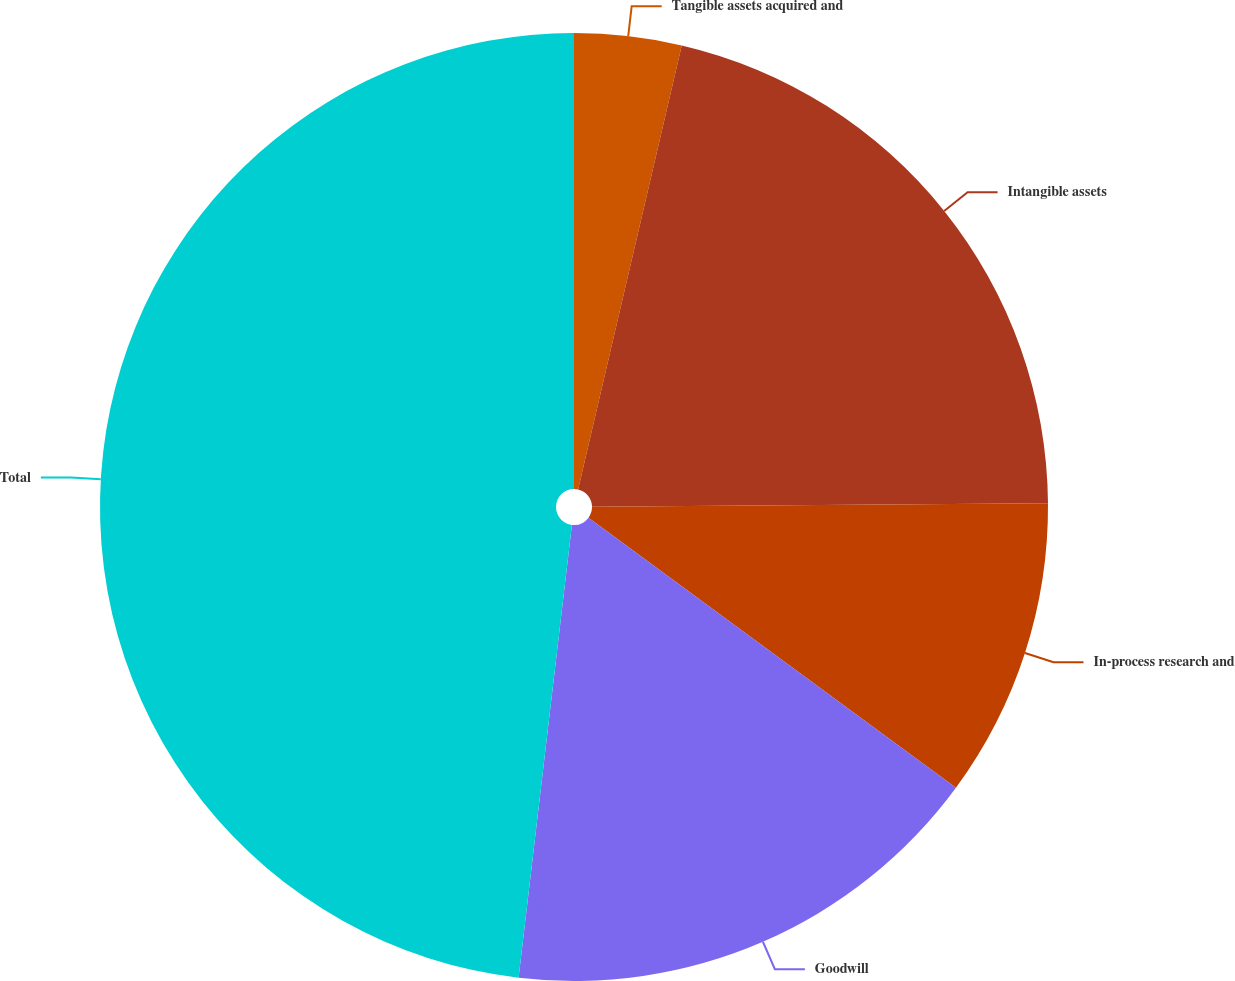Convert chart. <chart><loc_0><loc_0><loc_500><loc_500><pie_chart><fcel>Tangible assets acquired and<fcel>Intangible assets<fcel>In-process research and<fcel>Goodwill<fcel>Total<nl><fcel>3.65%<fcel>21.23%<fcel>10.21%<fcel>16.78%<fcel>48.14%<nl></chart> 